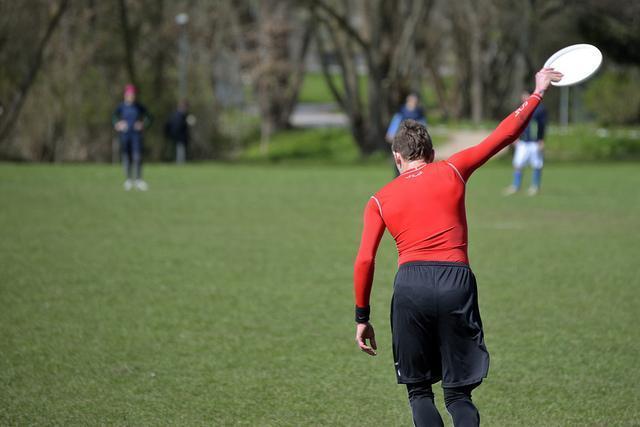How many people are on the field?
Give a very brief answer. 4. How many people can be seen?
Give a very brief answer. 2. How many bikes are below the outdoor wall decorations?
Give a very brief answer. 0. 